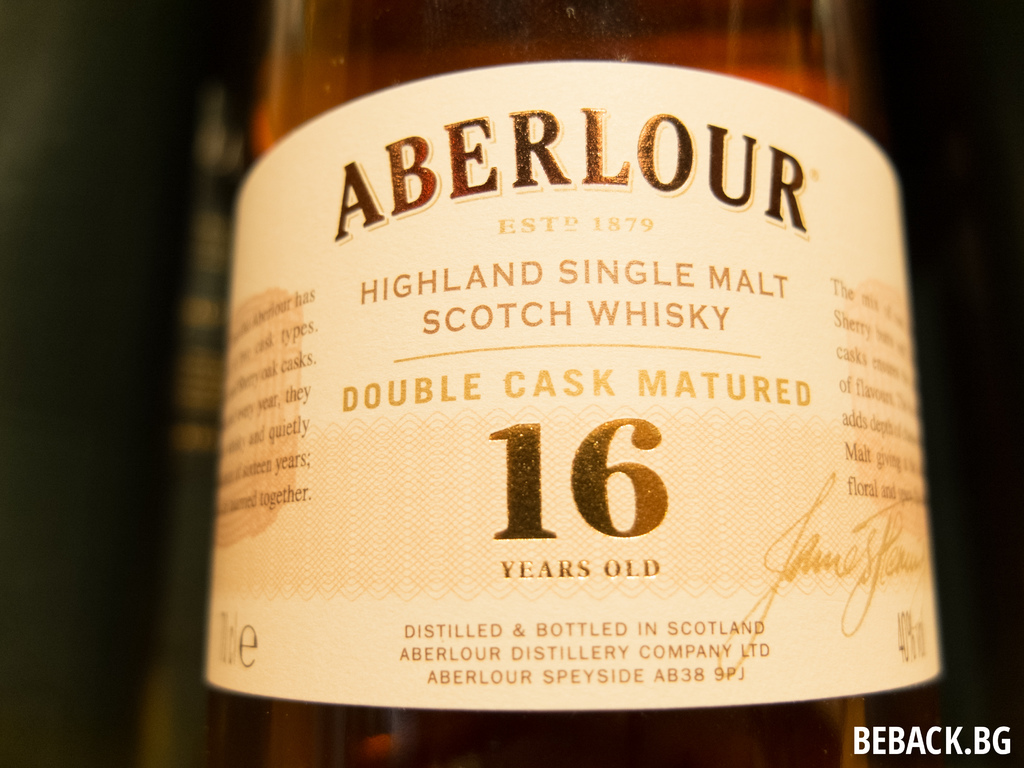What can you tell me about the history of the Aberlour Distillery? Aberlour Distillery was founded in 1879 by James Fleming in the heart of Scotland's Speyside region, known for producing single malt whiskies. The distillery is renowned for its rich heritage and commitment to traditional distilling methods, which prioritize quality and flavor. What makes Speyside a key region for Scotch whisky production? Speyside is acclaimed for its ideal conditions for whisky production, including its pure water sources, favorable climate, and abundant supply of barley. This region is distinguished by producing whiskies that are generally sweeter, smoother, and more floral in character. 